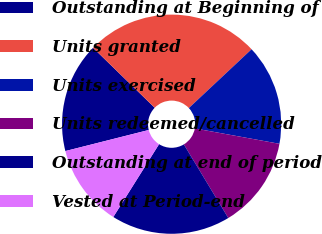<chart> <loc_0><loc_0><loc_500><loc_500><pie_chart><fcel>Outstanding at Beginning of<fcel>Units granted<fcel>Units exercised<fcel>Units redeemed/cancelled<fcel>Outstanding at end of period<fcel>Vested at Period-end<nl><fcel>16.22%<fcel>25.74%<fcel>14.85%<fcel>13.49%<fcel>17.58%<fcel>12.13%<nl></chart> 